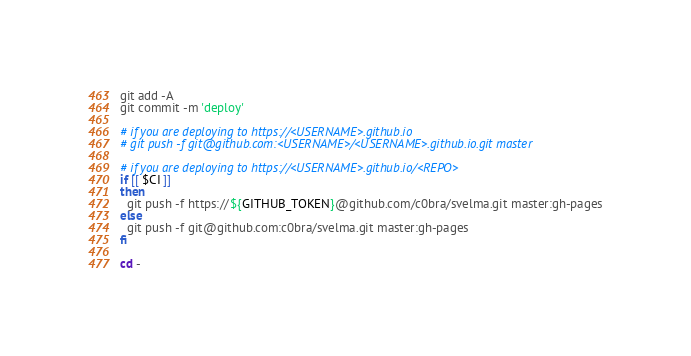<code> <loc_0><loc_0><loc_500><loc_500><_Bash_>git add -A
git commit -m 'deploy'

# if you are deploying to https://<USERNAME>.github.io
# git push -f git@github.com:<USERNAME>/<USERNAME>.github.io.git master

# if you are deploying to https://<USERNAME>.github.io/<REPO>
if [[ $CI ]]
then
  git push -f https://${GITHUB_TOKEN}@github.com/c0bra/svelma.git master:gh-pages
else
  git push -f git@github.com:c0bra/svelma.git master:gh-pages
fi

cd -</code> 